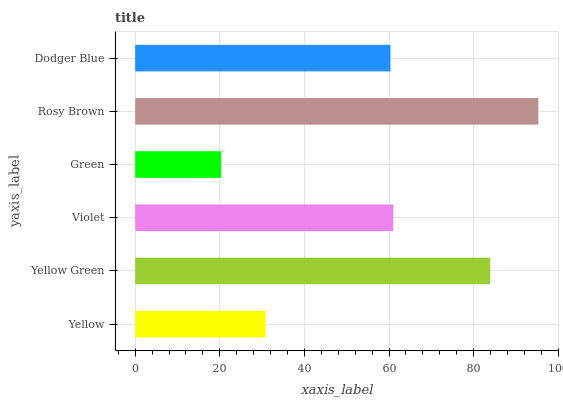Is Green the minimum?
Answer yes or no. Yes. Is Rosy Brown the maximum?
Answer yes or no. Yes. Is Yellow Green the minimum?
Answer yes or no. No. Is Yellow Green the maximum?
Answer yes or no. No. Is Yellow Green greater than Yellow?
Answer yes or no. Yes. Is Yellow less than Yellow Green?
Answer yes or no. Yes. Is Yellow greater than Yellow Green?
Answer yes or no. No. Is Yellow Green less than Yellow?
Answer yes or no. No. Is Violet the high median?
Answer yes or no. Yes. Is Dodger Blue the low median?
Answer yes or no. Yes. Is Dodger Blue the high median?
Answer yes or no. No. Is Green the low median?
Answer yes or no. No. 